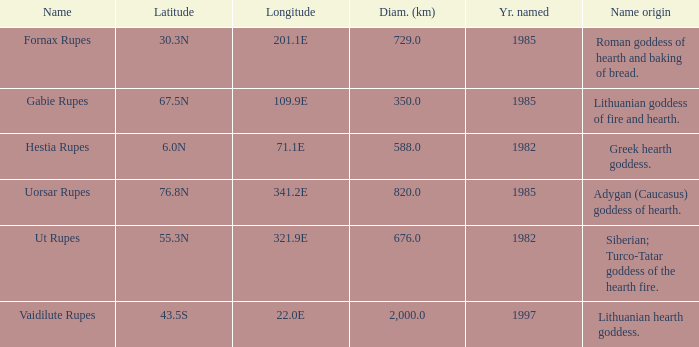What was the diameter of the feature found in 1997? 2000.0. 